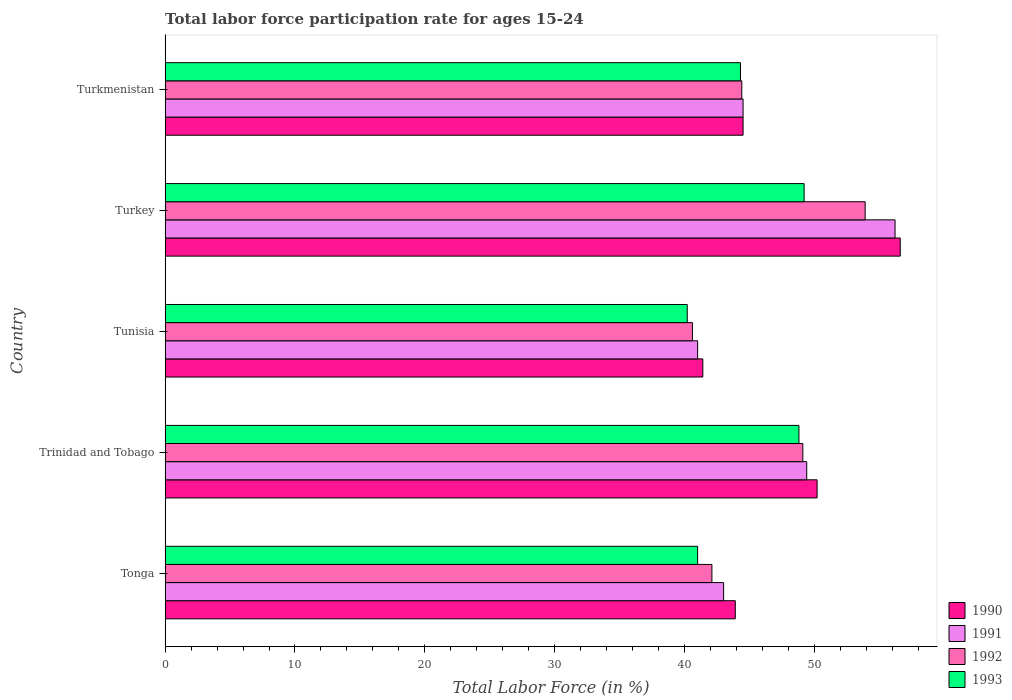Are the number of bars per tick equal to the number of legend labels?
Make the answer very short. Yes. How many bars are there on the 5th tick from the bottom?
Provide a short and direct response. 4. What is the label of the 5th group of bars from the top?
Make the answer very short. Tonga. What is the labor force participation rate in 1992 in Turkey?
Ensure brevity in your answer.  53.9. Across all countries, what is the maximum labor force participation rate in 1991?
Keep it short and to the point. 56.2. Across all countries, what is the minimum labor force participation rate in 1991?
Make the answer very short. 41. In which country was the labor force participation rate in 1992 maximum?
Offer a terse response. Turkey. In which country was the labor force participation rate in 1990 minimum?
Your answer should be very brief. Tunisia. What is the total labor force participation rate in 1992 in the graph?
Your answer should be compact. 230.1. What is the difference between the labor force participation rate in 1993 in Tunisia and the labor force participation rate in 1991 in Trinidad and Tobago?
Offer a very short reply. -9.2. What is the average labor force participation rate in 1990 per country?
Offer a terse response. 47.32. What is the difference between the labor force participation rate in 1991 and labor force participation rate in 1992 in Tonga?
Keep it short and to the point. 0.9. In how many countries, is the labor force participation rate in 1990 greater than 46 %?
Offer a terse response. 2. What is the ratio of the labor force participation rate in 1992 in Tunisia to that in Turkey?
Ensure brevity in your answer.  0.75. What is the difference between the highest and the second highest labor force participation rate in 1993?
Offer a very short reply. 0.4. What is the difference between the highest and the lowest labor force participation rate in 1993?
Offer a terse response. 9. What does the 1st bar from the top in Turkey represents?
Your answer should be compact. 1993. What does the 3rd bar from the bottom in Tunisia represents?
Provide a short and direct response. 1992. Is it the case that in every country, the sum of the labor force participation rate in 1993 and labor force participation rate in 1992 is greater than the labor force participation rate in 1990?
Your answer should be compact. Yes. Are all the bars in the graph horizontal?
Provide a succinct answer. Yes. Does the graph contain grids?
Offer a terse response. No. Where does the legend appear in the graph?
Offer a very short reply. Bottom right. How are the legend labels stacked?
Your answer should be very brief. Vertical. What is the title of the graph?
Your answer should be compact. Total labor force participation rate for ages 15-24. Does "1963" appear as one of the legend labels in the graph?
Make the answer very short. No. What is the label or title of the Y-axis?
Provide a succinct answer. Country. What is the Total Labor Force (in %) in 1990 in Tonga?
Your answer should be compact. 43.9. What is the Total Labor Force (in %) of 1991 in Tonga?
Offer a very short reply. 43. What is the Total Labor Force (in %) in 1992 in Tonga?
Offer a terse response. 42.1. What is the Total Labor Force (in %) in 1993 in Tonga?
Your answer should be compact. 41. What is the Total Labor Force (in %) in 1990 in Trinidad and Tobago?
Make the answer very short. 50.2. What is the Total Labor Force (in %) of 1991 in Trinidad and Tobago?
Provide a succinct answer. 49.4. What is the Total Labor Force (in %) in 1992 in Trinidad and Tobago?
Ensure brevity in your answer.  49.1. What is the Total Labor Force (in %) of 1993 in Trinidad and Tobago?
Provide a succinct answer. 48.8. What is the Total Labor Force (in %) in 1990 in Tunisia?
Give a very brief answer. 41.4. What is the Total Labor Force (in %) of 1991 in Tunisia?
Your answer should be compact. 41. What is the Total Labor Force (in %) in 1992 in Tunisia?
Make the answer very short. 40.6. What is the Total Labor Force (in %) of 1993 in Tunisia?
Give a very brief answer. 40.2. What is the Total Labor Force (in %) of 1990 in Turkey?
Provide a succinct answer. 56.6. What is the Total Labor Force (in %) in 1991 in Turkey?
Offer a very short reply. 56.2. What is the Total Labor Force (in %) of 1992 in Turkey?
Provide a short and direct response. 53.9. What is the Total Labor Force (in %) in 1993 in Turkey?
Provide a succinct answer. 49.2. What is the Total Labor Force (in %) of 1990 in Turkmenistan?
Provide a succinct answer. 44.5. What is the Total Labor Force (in %) in 1991 in Turkmenistan?
Your answer should be very brief. 44.5. What is the Total Labor Force (in %) in 1992 in Turkmenistan?
Provide a short and direct response. 44.4. What is the Total Labor Force (in %) of 1993 in Turkmenistan?
Your answer should be very brief. 44.3. Across all countries, what is the maximum Total Labor Force (in %) of 1990?
Provide a succinct answer. 56.6. Across all countries, what is the maximum Total Labor Force (in %) of 1991?
Keep it short and to the point. 56.2. Across all countries, what is the maximum Total Labor Force (in %) in 1992?
Keep it short and to the point. 53.9. Across all countries, what is the maximum Total Labor Force (in %) in 1993?
Your answer should be very brief. 49.2. Across all countries, what is the minimum Total Labor Force (in %) of 1990?
Your answer should be compact. 41.4. Across all countries, what is the minimum Total Labor Force (in %) in 1991?
Your answer should be compact. 41. Across all countries, what is the minimum Total Labor Force (in %) in 1992?
Provide a succinct answer. 40.6. Across all countries, what is the minimum Total Labor Force (in %) in 1993?
Your answer should be very brief. 40.2. What is the total Total Labor Force (in %) of 1990 in the graph?
Ensure brevity in your answer.  236.6. What is the total Total Labor Force (in %) in 1991 in the graph?
Offer a very short reply. 234.1. What is the total Total Labor Force (in %) of 1992 in the graph?
Your answer should be compact. 230.1. What is the total Total Labor Force (in %) in 1993 in the graph?
Your response must be concise. 223.5. What is the difference between the Total Labor Force (in %) of 1990 in Tonga and that in Trinidad and Tobago?
Keep it short and to the point. -6.3. What is the difference between the Total Labor Force (in %) of 1992 in Tonga and that in Trinidad and Tobago?
Your answer should be very brief. -7. What is the difference between the Total Labor Force (in %) of 1993 in Tonga and that in Tunisia?
Your response must be concise. 0.8. What is the difference between the Total Labor Force (in %) of 1990 in Tonga and that in Turkey?
Keep it short and to the point. -12.7. What is the difference between the Total Labor Force (in %) in 1992 in Tonga and that in Turkey?
Ensure brevity in your answer.  -11.8. What is the difference between the Total Labor Force (in %) in 1991 in Tonga and that in Turkmenistan?
Ensure brevity in your answer.  -1.5. What is the difference between the Total Labor Force (in %) of 1992 in Tonga and that in Turkmenistan?
Provide a short and direct response. -2.3. What is the difference between the Total Labor Force (in %) in 1993 in Tonga and that in Turkmenistan?
Offer a terse response. -3.3. What is the difference between the Total Labor Force (in %) of 1990 in Trinidad and Tobago and that in Tunisia?
Provide a succinct answer. 8.8. What is the difference between the Total Labor Force (in %) of 1992 in Trinidad and Tobago and that in Tunisia?
Make the answer very short. 8.5. What is the difference between the Total Labor Force (in %) in 1990 in Trinidad and Tobago and that in Turkey?
Keep it short and to the point. -6.4. What is the difference between the Total Labor Force (in %) of 1990 in Trinidad and Tobago and that in Turkmenistan?
Keep it short and to the point. 5.7. What is the difference between the Total Labor Force (in %) in 1991 in Trinidad and Tobago and that in Turkmenistan?
Ensure brevity in your answer.  4.9. What is the difference between the Total Labor Force (in %) of 1992 in Trinidad and Tobago and that in Turkmenistan?
Make the answer very short. 4.7. What is the difference between the Total Labor Force (in %) of 1990 in Tunisia and that in Turkey?
Offer a very short reply. -15.2. What is the difference between the Total Labor Force (in %) of 1991 in Tunisia and that in Turkey?
Make the answer very short. -15.2. What is the difference between the Total Labor Force (in %) in 1993 in Tunisia and that in Turkey?
Ensure brevity in your answer.  -9. What is the difference between the Total Labor Force (in %) in 1991 in Tunisia and that in Turkmenistan?
Your answer should be very brief. -3.5. What is the difference between the Total Labor Force (in %) in 1992 in Tunisia and that in Turkmenistan?
Your answer should be compact. -3.8. What is the difference between the Total Labor Force (in %) in 1993 in Tunisia and that in Turkmenistan?
Provide a succinct answer. -4.1. What is the difference between the Total Labor Force (in %) of 1992 in Turkey and that in Turkmenistan?
Provide a short and direct response. 9.5. What is the difference between the Total Labor Force (in %) of 1993 in Turkey and that in Turkmenistan?
Your response must be concise. 4.9. What is the difference between the Total Labor Force (in %) in 1990 in Tonga and the Total Labor Force (in %) in 1993 in Trinidad and Tobago?
Your answer should be very brief. -4.9. What is the difference between the Total Labor Force (in %) of 1991 in Tonga and the Total Labor Force (in %) of 1992 in Trinidad and Tobago?
Keep it short and to the point. -6.1. What is the difference between the Total Labor Force (in %) of 1990 in Tonga and the Total Labor Force (in %) of 1991 in Tunisia?
Your response must be concise. 2.9. What is the difference between the Total Labor Force (in %) in 1990 in Tonga and the Total Labor Force (in %) in 1993 in Tunisia?
Provide a short and direct response. 3.7. What is the difference between the Total Labor Force (in %) of 1991 in Tonga and the Total Labor Force (in %) of 1993 in Tunisia?
Give a very brief answer. 2.8. What is the difference between the Total Labor Force (in %) of 1990 in Tonga and the Total Labor Force (in %) of 1991 in Turkey?
Provide a short and direct response. -12.3. What is the difference between the Total Labor Force (in %) of 1990 in Tonga and the Total Labor Force (in %) of 1992 in Turkey?
Offer a very short reply. -10. What is the difference between the Total Labor Force (in %) in 1991 in Tonga and the Total Labor Force (in %) in 1992 in Turkey?
Provide a succinct answer. -10.9. What is the difference between the Total Labor Force (in %) of 1991 in Tonga and the Total Labor Force (in %) of 1993 in Turkey?
Give a very brief answer. -6.2. What is the difference between the Total Labor Force (in %) of 1990 in Tonga and the Total Labor Force (in %) of 1991 in Turkmenistan?
Provide a short and direct response. -0.6. What is the difference between the Total Labor Force (in %) of 1990 in Tonga and the Total Labor Force (in %) of 1992 in Turkmenistan?
Your answer should be compact. -0.5. What is the difference between the Total Labor Force (in %) of 1990 in Tonga and the Total Labor Force (in %) of 1993 in Turkmenistan?
Offer a very short reply. -0.4. What is the difference between the Total Labor Force (in %) in 1991 in Tonga and the Total Labor Force (in %) in 1992 in Turkmenistan?
Offer a terse response. -1.4. What is the difference between the Total Labor Force (in %) of 1991 in Tonga and the Total Labor Force (in %) of 1993 in Turkmenistan?
Keep it short and to the point. -1.3. What is the difference between the Total Labor Force (in %) of 1992 in Tonga and the Total Labor Force (in %) of 1993 in Turkmenistan?
Provide a short and direct response. -2.2. What is the difference between the Total Labor Force (in %) in 1990 in Trinidad and Tobago and the Total Labor Force (in %) in 1992 in Tunisia?
Your response must be concise. 9.6. What is the difference between the Total Labor Force (in %) of 1990 in Trinidad and Tobago and the Total Labor Force (in %) of 1993 in Tunisia?
Offer a very short reply. 10. What is the difference between the Total Labor Force (in %) in 1991 in Trinidad and Tobago and the Total Labor Force (in %) in 1993 in Tunisia?
Your answer should be compact. 9.2. What is the difference between the Total Labor Force (in %) of 1992 in Trinidad and Tobago and the Total Labor Force (in %) of 1993 in Tunisia?
Your answer should be compact. 8.9. What is the difference between the Total Labor Force (in %) in 1990 in Trinidad and Tobago and the Total Labor Force (in %) in 1993 in Turkey?
Provide a short and direct response. 1. What is the difference between the Total Labor Force (in %) in 1991 in Trinidad and Tobago and the Total Labor Force (in %) in 1993 in Turkey?
Your answer should be compact. 0.2. What is the difference between the Total Labor Force (in %) of 1990 in Trinidad and Tobago and the Total Labor Force (in %) of 1991 in Turkmenistan?
Offer a very short reply. 5.7. What is the difference between the Total Labor Force (in %) of 1990 in Trinidad and Tobago and the Total Labor Force (in %) of 1992 in Turkmenistan?
Keep it short and to the point. 5.8. What is the difference between the Total Labor Force (in %) in 1991 in Trinidad and Tobago and the Total Labor Force (in %) in 1992 in Turkmenistan?
Provide a succinct answer. 5. What is the difference between the Total Labor Force (in %) in 1990 in Tunisia and the Total Labor Force (in %) in 1991 in Turkey?
Your answer should be compact. -14.8. What is the difference between the Total Labor Force (in %) in 1990 in Tunisia and the Total Labor Force (in %) in 1993 in Turkey?
Your answer should be very brief. -7.8. What is the difference between the Total Labor Force (in %) of 1991 in Tunisia and the Total Labor Force (in %) of 1993 in Turkey?
Offer a very short reply. -8.2. What is the difference between the Total Labor Force (in %) of 1990 in Tunisia and the Total Labor Force (in %) of 1991 in Turkmenistan?
Keep it short and to the point. -3.1. What is the difference between the Total Labor Force (in %) of 1990 in Tunisia and the Total Labor Force (in %) of 1992 in Turkmenistan?
Make the answer very short. -3. What is the difference between the Total Labor Force (in %) of 1991 in Tunisia and the Total Labor Force (in %) of 1992 in Turkmenistan?
Make the answer very short. -3.4. What is the difference between the Total Labor Force (in %) in 1992 in Tunisia and the Total Labor Force (in %) in 1993 in Turkmenistan?
Offer a terse response. -3.7. What is the difference between the Total Labor Force (in %) in 1992 in Turkey and the Total Labor Force (in %) in 1993 in Turkmenistan?
Offer a very short reply. 9.6. What is the average Total Labor Force (in %) in 1990 per country?
Provide a short and direct response. 47.32. What is the average Total Labor Force (in %) of 1991 per country?
Make the answer very short. 46.82. What is the average Total Labor Force (in %) of 1992 per country?
Make the answer very short. 46.02. What is the average Total Labor Force (in %) of 1993 per country?
Provide a succinct answer. 44.7. What is the difference between the Total Labor Force (in %) of 1990 and Total Labor Force (in %) of 1991 in Tonga?
Offer a very short reply. 0.9. What is the difference between the Total Labor Force (in %) in 1990 and Total Labor Force (in %) in 1993 in Tonga?
Your answer should be compact. 2.9. What is the difference between the Total Labor Force (in %) in 1991 and Total Labor Force (in %) in 1993 in Tonga?
Provide a succinct answer. 2. What is the difference between the Total Labor Force (in %) of 1992 and Total Labor Force (in %) of 1993 in Tonga?
Offer a very short reply. 1.1. What is the difference between the Total Labor Force (in %) in 1991 and Total Labor Force (in %) in 1992 in Trinidad and Tobago?
Your answer should be compact. 0.3. What is the difference between the Total Labor Force (in %) of 1992 and Total Labor Force (in %) of 1993 in Trinidad and Tobago?
Ensure brevity in your answer.  0.3. What is the difference between the Total Labor Force (in %) in 1990 and Total Labor Force (in %) in 1991 in Tunisia?
Keep it short and to the point. 0.4. What is the difference between the Total Labor Force (in %) of 1990 and Total Labor Force (in %) of 1992 in Tunisia?
Your response must be concise. 0.8. What is the difference between the Total Labor Force (in %) of 1990 and Total Labor Force (in %) of 1993 in Tunisia?
Offer a terse response. 1.2. What is the difference between the Total Labor Force (in %) in 1991 and Total Labor Force (in %) in 1992 in Tunisia?
Keep it short and to the point. 0.4. What is the difference between the Total Labor Force (in %) in 1990 and Total Labor Force (in %) in 1993 in Turkey?
Provide a short and direct response. 7.4. What is the difference between the Total Labor Force (in %) in 1990 and Total Labor Force (in %) in 1991 in Turkmenistan?
Ensure brevity in your answer.  0. What is the difference between the Total Labor Force (in %) in 1992 and Total Labor Force (in %) in 1993 in Turkmenistan?
Provide a succinct answer. 0.1. What is the ratio of the Total Labor Force (in %) in 1990 in Tonga to that in Trinidad and Tobago?
Make the answer very short. 0.87. What is the ratio of the Total Labor Force (in %) in 1991 in Tonga to that in Trinidad and Tobago?
Provide a short and direct response. 0.87. What is the ratio of the Total Labor Force (in %) of 1992 in Tonga to that in Trinidad and Tobago?
Your response must be concise. 0.86. What is the ratio of the Total Labor Force (in %) of 1993 in Tonga to that in Trinidad and Tobago?
Offer a terse response. 0.84. What is the ratio of the Total Labor Force (in %) of 1990 in Tonga to that in Tunisia?
Provide a short and direct response. 1.06. What is the ratio of the Total Labor Force (in %) of 1991 in Tonga to that in Tunisia?
Give a very brief answer. 1.05. What is the ratio of the Total Labor Force (in %) in 1992 in Tonga to that in Tunisia?
Your answer should be compact. 1.04. What is the ratio of the Total Labor Force (in %) in 1993 in Tonga to that in Tunisia?
Ensure brevity in your answer.  1.02. What is the ratio of the Total Labor Force (in %) of 1990 in Tonga to that in Turkey?
Offer a very short reply. 0.78. What is the ratio of the Total Labor Force (in %) in 1991 in Tonga to that in Turkey?
Keep it short and to the point. 0.77. What is the ratio of the Total Labor Force (in %) of 1992 in Tonga to that in Turkey?
Your response must be concise. 0.78. What is the ratio of the Total Labor Force (in %) in 1993 in Tonga to that in Turkey?
Your answer should be very brief. 0.83. What is the ratio of the Total Labor Force (in %) in 1990 in Tonga to that in Turkmenistan?
Your answer should be very brief. 0.99. What is the ratio of the Total Labor Force (in %) of 1991 in Tonga to that in Turkmenistan?
Your answer should be very brief. 0.97. What is the ratio of the Total Labor Force (in %) in 1992 in Tonga to that in Turkmenistan?
Your answer should be very brief. 0.95. What is the ratio of the Total Labor Force (in %) of 1993 in Tonga to that in Turkmenistan?
Keep it short and to the point. 0.93. What is the ratio of the Total Labor Force (in %) of 1990 in Trinidad and Tobago to that in Tunisia?
Ensure brevity in your answer.  1.21. What is the ratio of the Total Labor Force (in %) in 1991 in Trinidad and Tobago to that in Tunisia?
Keep it short and to the point. 1.2. What is the ratio of the Total Labor Force (in %) of 1992 in Trinidad and Tobago to that in Tunisia?
Your answer should be very brief. 1.21. What is the ratio of the Total Labor Force (in %) in 1993 in Trinidad and Tobago to that in Tunisia?
Ensure brevity in your answer.  1.21. What is the ratio of the Total Labor Force (in %) in 1990 in Trinidad and Tobago to that in Turkey?
Provide a short and direct response. 0.89. What is the ratio of the Total Labor Force (in %) of 1991 in Trinidad and Tobago to that in Turkey?
Provide a short and direct response. 0.88. What is the ratio of the Total Labor Force (in %) in 1992 in Trinidad and Tobago to that in Turkey?
Keep it short and to the point. 0.91. What is the ratio of the Total Labor Force (in %) of 1993 in Trinidad and Tobago to that in Turkey?
Your response must be concise. 0.99. What is the ratio of the Total Labor Force (in %) of 1990 in Trinidad and Tobago to that in Turkmenistan?
Give a very brief answer. 1.13. What is the ratio of the Total Labor Force (in %) in 1991 in Trinidad and Tobago to that in Turkmenistan?
Your answer should be very brief. 1.11. What is the ratio of the Total Labor Force (in %) of 1992 in Trinidad and Tobago to that in Turkmenistan?
Provide a short and direct response. 1.11. What is the ratio of the Total Labor Force (in %) in 1993 in Trinidad and Tobago to that in Turkmenistan?
Offer a terse response. 1.1. What is the ratio of the Total Labor Force (in %) in 1990 in Tunisia to that in Turkey?
Offer a very short reply. 0.73. What is the ratio of the Total Labor Force (in %) in 1991 in Tunisia to that in Turkey?
Keep it short and to the point. 0.73. What is the ratio of the Total Labor Force (in %) in 1992 in Tunisia to that in Turkey?
Keep it short and to the point. 0.75. What is the ratio of the Total Labor Force (in %) in 1993 in Tunisia to that in Turkey?
Keep it short and to the point. 0.82. What is the ratio of the Total Labor Force (in %) of 1990 in Tunisia to that in Turkmenistan?
Keep it short and to the point. 0.93. What is the ratio of the Total Labor Force (in %) in 1991 in Tunisia to that in Turkmenistan?
Keep it short and to the point. 0.92. What is the ratio of the Total Labor Force (in %) in 1992 in Tunisia to that in Turkmenistan?
Offer a very short reply. 0.91. What is the ratio of the Total Labor Force (in %) in 1993 in Tunisia to that in Turkmenistan?
Your response must be concise. 0.91. What is the ratio of the Total Labor Force (in %) in 1990 in Turkey to that in Turkmenistan?
Give a very brief answer. 1.27. What is the ratio of the Total Labor Force (in %) in 1991 in Turkey to that in Turkmenistan?
Your answer should be very brief. 1.26. What is the ratio of the Total Labor Force (in %) in 1992 in Turkey to that in Turkmenistan?
Give a very brief answer. 1.21. What is the ratio of the Total Labor Force (in %) in 1993 in Turkey to that in Turkmenistan?
Make the answer very short. 1.11. What is the difference between the highest and the second highest Total Labor Force (in %) in 1991?
Your answer should be very brief. 6.8. What is the difference between the highest and the second highest Total Labor Force (in %) in 1992?
Offer a very short reply. 4.8. What is the difference between the highest and the lowest Total Labor Force (in %) in 1991?
Make the answer very short. 15.2. What is the difference between the highest and the lowest Total Labor Force (in %) of 1993?
Your answer should be very brief. 9. 